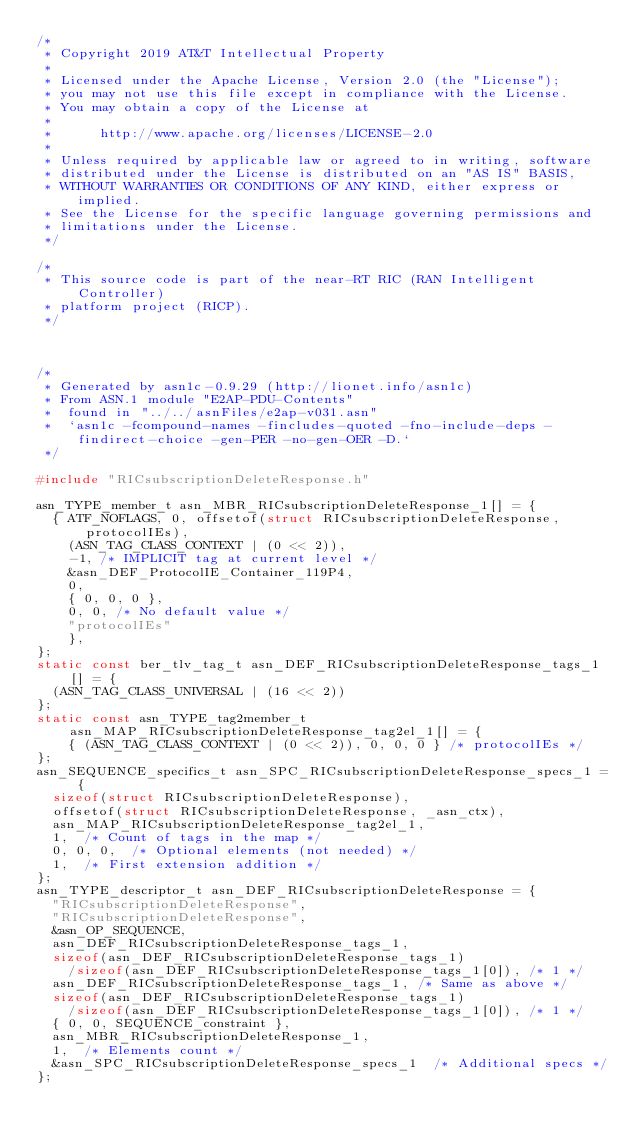Convert code to text. <code><loc_0><loc_0><loc_500><loc_500><_C_>/*
 * Copyright 2019 AT&T Intellectual Property
 *
 * Licensed under the Apache License, Version 2.0 (the "License");
 * you may not use this file except in compliance with the License.
 * You may obtain a copy of the License at
 *
 *      http://www.apache.org/licenses/LICENSE-2.0
 *
 * Unless required by applicable law or agreed to in writing, software
 * distributed under the License is distributed on an "AS IS" BASIS,
 * WITHOUT WARRANTIES OR CONDITIONS OF ANY KIND, either express or implied.
 * See the License for the specific language governing permissions and
 * limitations under the License.
 */

/*
 * This source code is part of the near-RT RIC (RAN Intelligent Controller)
 * platform project (RICP).
 */



/*
 * Generated by asn1c-0.9.29 (http://lionet.info/asn1c)
 * From ASN.1 module "E2AP-PDU-Contents"
 * 	found in "../../asnFiles/e2ap-v031.asn"
 * 	`asn1c -fcompound-names -fincludes-quoted -fno-include-deps -findirect-choice -gen-PER -no-gen-OER -D.`
 */

#include "RICsubscriptionDeleteResponse.h"

asn_TYPE_member_t asn_MBR_RICsubscriptionDeleteResponse_1[] = {
	{ ATF_NOFLAGS, 0, offsetof(struct RICsubscriptionDeleteResponse, protocolIEs),
		(ASN_TAG_CLASS_CONTEXT | (0 << 2)),
		-1,	/* IMPLICIT tag at current level */
		&asn_DEF_ProtocolIE_Container_119P4,
		0,
		{ 0, 0, 0 },
		0, 0, /* No default value */
		"protocolIEs"
		},
};
static const ber_tlv_tag_t asn_DEF_RICsubscriptionDeleteResponse_tags_1[] = {
	(ASN_TAG_CLASS_UNIVERSAL | (16 << 2))
};
static const asn_TYPE_tag2member_t asn_MAP_RICsubscriptionDeleteResponse_tag2el_1[] = {
    { (ASN_TAG_CLASS_CONTEXT | (0 << 2)), 0, 0, 0 } /* protocolIEs */
};
asn_SEQUENCE_specifics_t asn_SPC_RICsubscriptionDeleteResponse_specs_1 = {
	sizeof(struct RICsubscriptionDeleteResponse),
	offsetof(struct RICsubscriptionDeleteResponse, _asn_ctx),
	asn_MAP_RICsubscriptionDeleteResponse_tag2el_1,
	1,	/* Count of tags in the map */
	0, 0, 0,	/* Optional elements (not needed) */
	1,	/* First extension addition */
};
asn_TYPE_descriptor_t asn_DEF_RICsubscriptionDeleteResponse = {
	"RICsubscriptionDeleteResponse",
	"RICsubscriptionDeleteResponse",
	&asn_OP_SEQUENCE,
	asn_DEF_RICsubscriptionDeleteResponse_tags_1,
	sizeof(asn_DEF_RICsubscriptionDeleteResponse_tags_1)
		/sizeof(asn_DEF_RICsubscriptionDeleteResponse_tags_1[0]), /* 1 */
	asn_DEF_RICsubscriptionDeleteResponse_tags_1,	/* Same as above */
	sizeof(asn_DEF_RICsubscriptionDeleteResponse_tags_1)
		/sizeof(asn_DEF_RICsubscriptionDeleteResponse_tags_1[0]), /* 1 */
	{ 0, 0, SEQUENCE_constraint },
	asn_MBR_RICsubscriptionDeleteResponse_1,
	1,	/* Elements count */
	&asn_SPC_RICsubscriptionDeleteResponse_specs_1	/* Additional specs */
};

</code> 